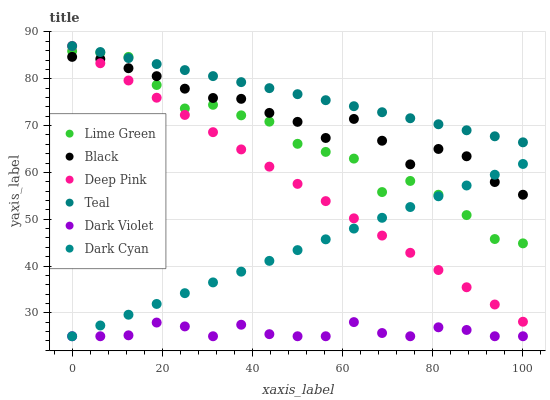Does Dark Violet have the minimum area under the curve?
Answer yes or no. Yes. Does Teal have the maximum area under the curve?
Answer yes or no. Yes. Does Black have the minimum area under the curve?
Answer yes or no. No. Does Black have the maximum area under the curve?
Answer yes or no. No. Is Deep Pink the smoothest?
Answer yes or no. Yes. Is Lime Green the roughest?
Answer yes or no. Yes. Is Dark Violet the smoothest?
Answer yes or no. No. Is Dark Violet the roughest?
Answer yes or no. No. Does Dark Violet have the lowest value?
Answer yes or no. Yes. Does Black have the lowest value?
Answer yes or no. No. Does Teal have the highest value?
Answer yes or no. Yes. Does Black have the highest value?
Answer yes or no. No. Is Dark Violet less than Teal?
Answer yes or no. Yes. Is Teal greater than Dark Cyan?
Answer yes or no. Yes. Does Deep Pink intersect Teal?
Answer yes or no. Yes. Is Deep Pink less than Teal?
Answer yes or no. No. Is Deep Pink greater than Teal?
Answer yes or no. No. Does Dark Violet intersect Teal?
Answer yes or no. No. 